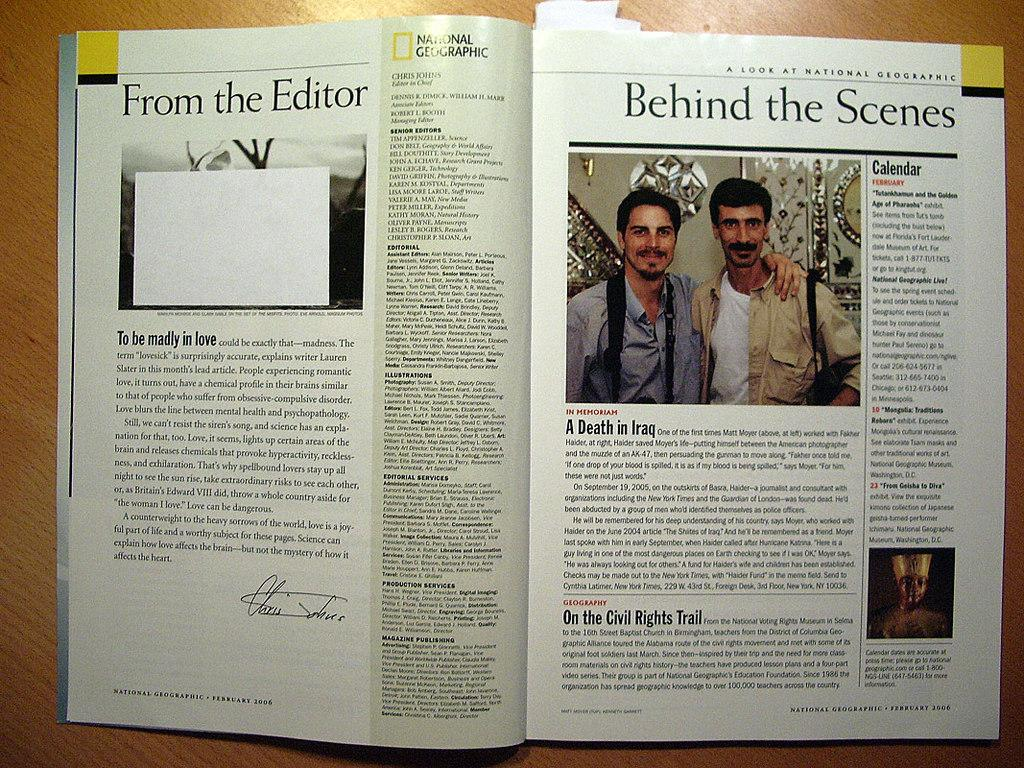<image>
Summarize the visual content of the image. an open book that is titled 'behind the scenes' on one page 